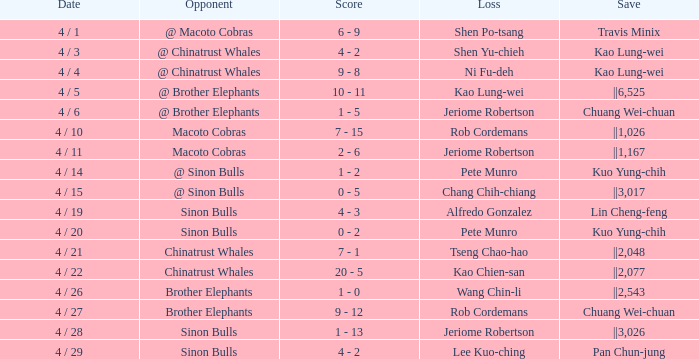Who obtained the save in the contest against the sinon bulls when jeriome robertson experienced the loss? ||3,026. 